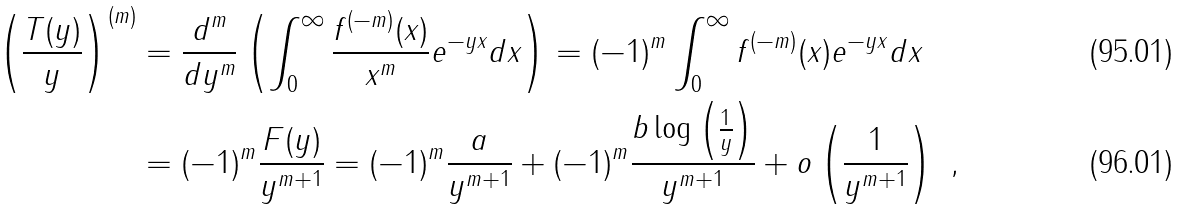<formula> <loc_0><loc_0><loc_500><loc_500>\left ( \frac { T ( y ) } { y } \right ) ^ { ( m ) } & = \frac { d ^ { m } } { d y ^ { m } } \left ( \int ^ { \infty } _ { 0 } \frac { f ^ { ( - m ) } ( x ) } { x ^ { m } } e ^ { - y x } d x \right ) = ( - 1 ) ^ { m } \int ^ { \infty } _ { 0 } f ^ { ( - m ) } ( x ) e ^ { - y x } d x \\ & = ( - 1 ) ^ { m } \frac { F ( y ) } { y ^ { m + 1 } } = ( - 1 ) ^ { m } \frac { a } { y ^ { m + 1 } } + ( - 1 ) ^ { m } \frac { b \log \left ( \frac { 1 } { y } \right ) } { y ^ { m + 1 } } + o \left ( \frac { 1 } { y ^ { m + 1 } } \right ) \ ,</formula> 